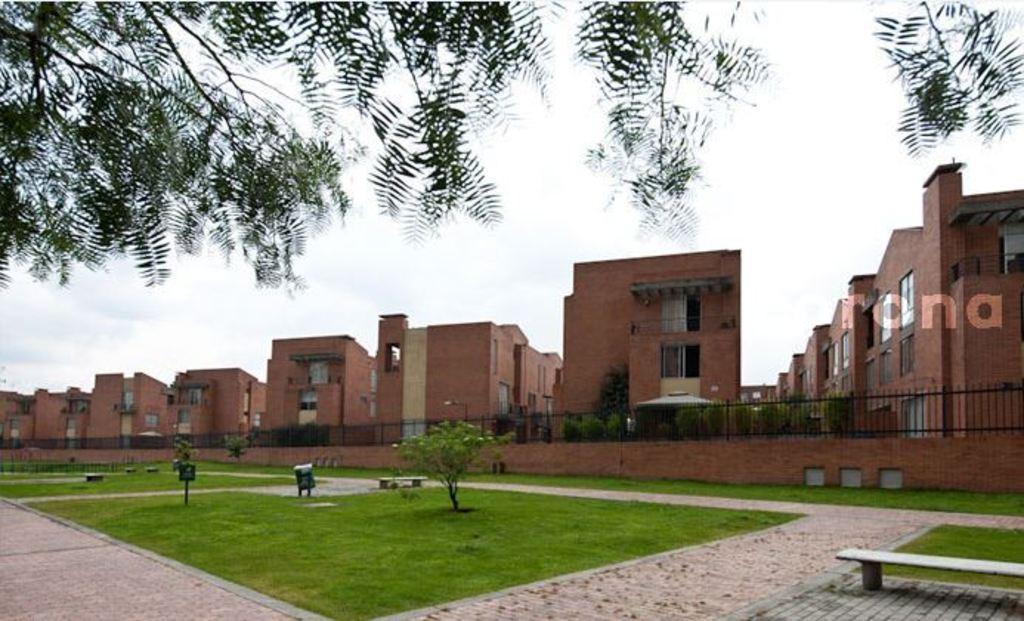Describe this image in one or two sentences. In the center of the image we can see a group of buildings, metal railing, trees. To the right side of the image we can see a bench placed on the ground. In the background, we can see a group of trees and sky. 